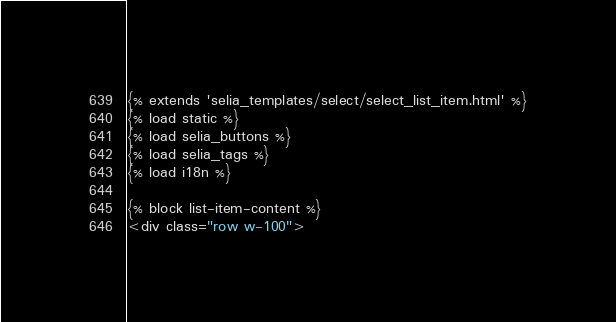<code> <loc_0><loc_0><loc_500><loc_500><_HTML_>{% extends 'selia_templates/select/select_list_item.html' %}
{% load static %}
{% load selia_buttons %}
{% load selia_tags %}
{% load i18n %}

{% block list-item-content %}
<div class="row w-100"></code> 